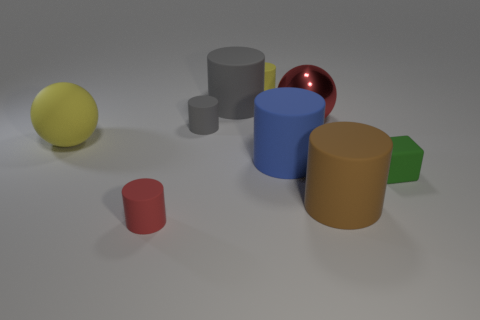Subtract all tiny yellow cylinders. How many cylinders are left? 5 Subtract all spheres. How many objects are left? 7 Subtract all red cylinders. How many cylinders are left? 5 Subtract all yellow cylinders. Subtract all blue cubes. How many cylinders are left? 5 Subtract all green cylinders. How many red balls are left? 1 Subtract all big cyan cylinders. Subtract all large brown cylinders. How many objects are left? 8 Add 2 big blue things. How many big blue things are left? 3 Add 4 matte blocks. How many matte blocks exist? 5 Subtract 0 green cylinders. How many objects are left? 9 Subtract 1 spheres. How many spheres are left? 1 